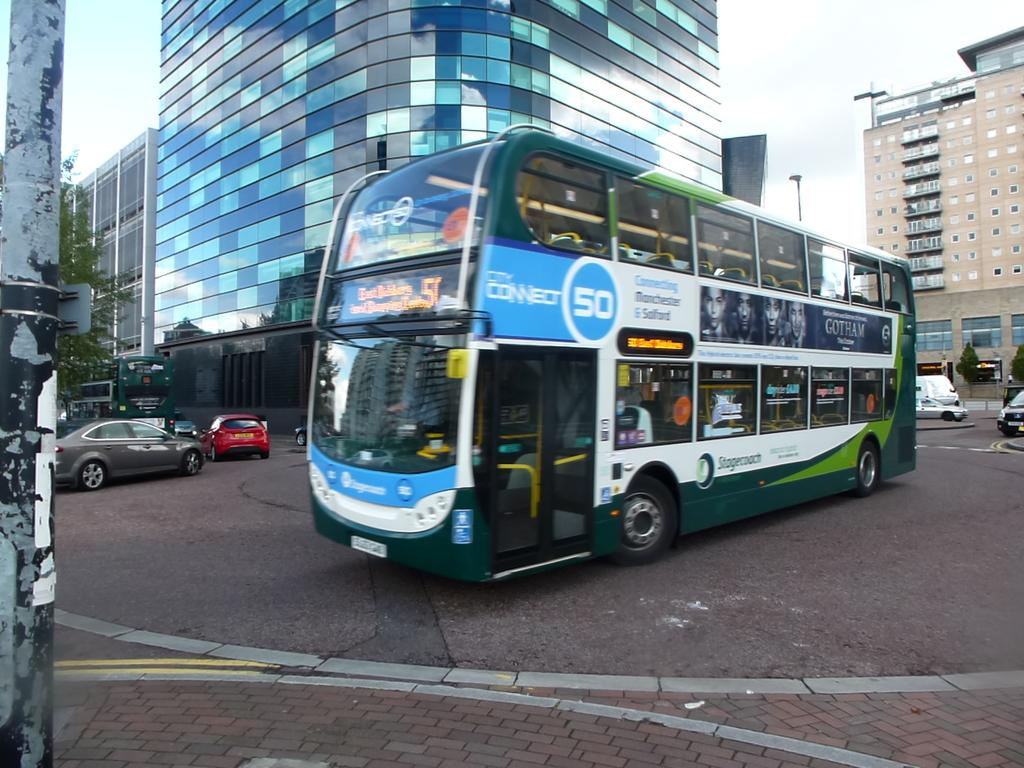What structures are present in the image? There are poles, a light, vehicles on the road, buildings, and trees in the image. What type of transportation can be seen on the road? Vehicles can be seen on the road in the image. What is visible in the background of the image? The sky is visible in the background of the image. What type of ink is being used by the bee in the image? There is no bee present in the image, and therefore no ink or bee-related activity can be observed. What type of tank is visible in the image? There is no tank present in the image. 